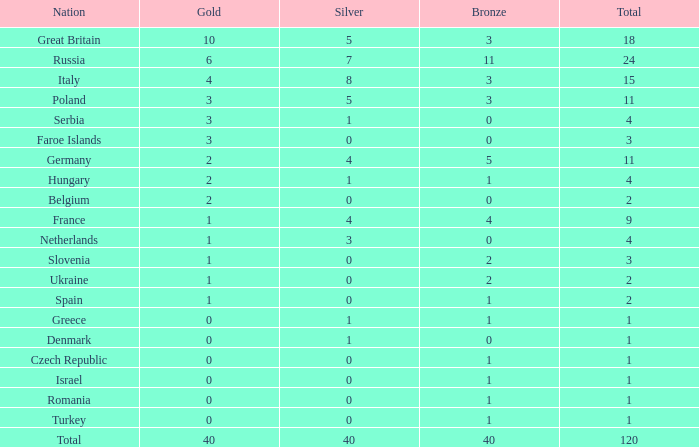What is the typical gold entry for the netherlands when there is also a non-zero bronze entry? None. 